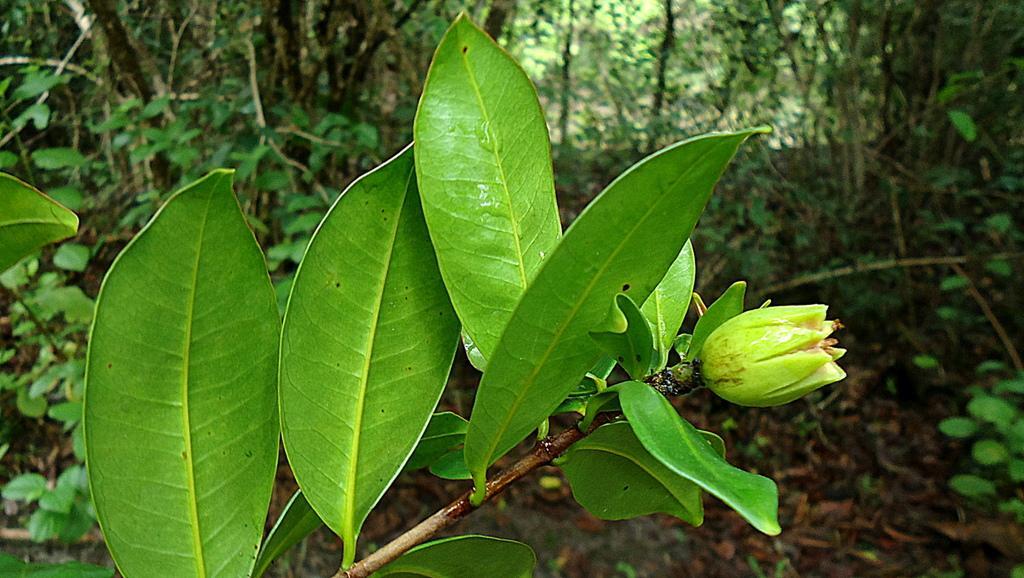Can you describe this image briefly? In this image we can see a flower, stem and leaves. In the background, we can see trees. 